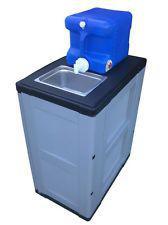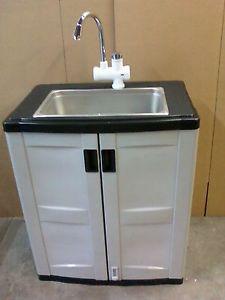The first image is the image on the left, the second image is the image on the right. Considering the images on both sides, is "A sink unit has a rectangular double-door cabinet underneath at least one rectangular inset sink." valid? Answer yes or no. Yes. The first image is the image on the left, the second image is the image on the right. Given the left and right images, does the statement "A sink cabinet stands flush against a wall and has two full-length front panel doors that open at the center, with black handles at upper center," hold true? Answer yes or no. Yes. 